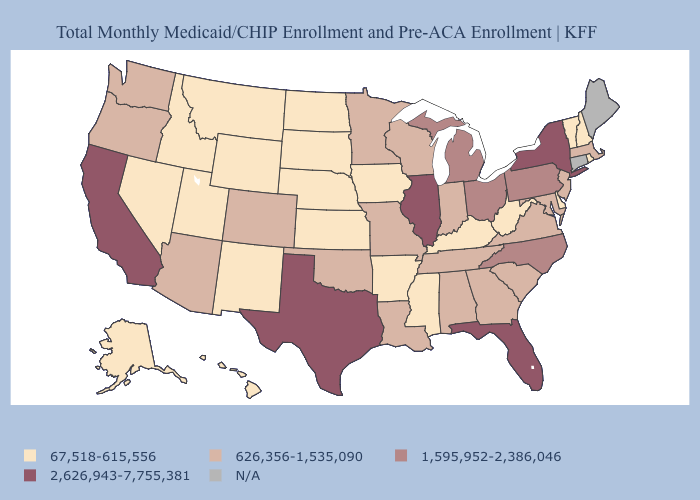Is the legend a continuous bar?
Concise answer only. No. Name the states that have a value in the range 626,356-1,535,090?
Write a very short answer. Alabama, Arizona, Colorado, Georgia, Indiana, Louisiana, Maryland, Massachusetts, Minnesota, Missouri, New Jersey, Oklahoma, Oregon, South Carolina, Tennessee, Virginia, Washington, Wisconsin. Does Illinois have the highest value in the MidWest?
Quick response, please. Yes. What is the value of Wisconsin?
Short answer required. 626,356-1,535,090. What is the highest value in the MidWest ?
Keep it brief. 2,626,943-7,755,381. What is the value of Connecticut?
Answer briefly. N/A. Which states have the highest value in the USA?
Write a very short answer. California, Florida, Illinois, New York, Texas. Name the states that have a value in the range 1,595,952-2,386,046?
Give a very brief answer. Michigan, North Carolina, Ohio, Pennsylvania. What is the value of Alabama?
Short answer required. 626,356-1,535,090. What is the value of Ohio?
Be succinct. 1,595,952-2,386,046. Which states hav the highest value in the South?
Answer briefly. Florida, Texas. What is the value of Maine?
Be succinct. N/A. 